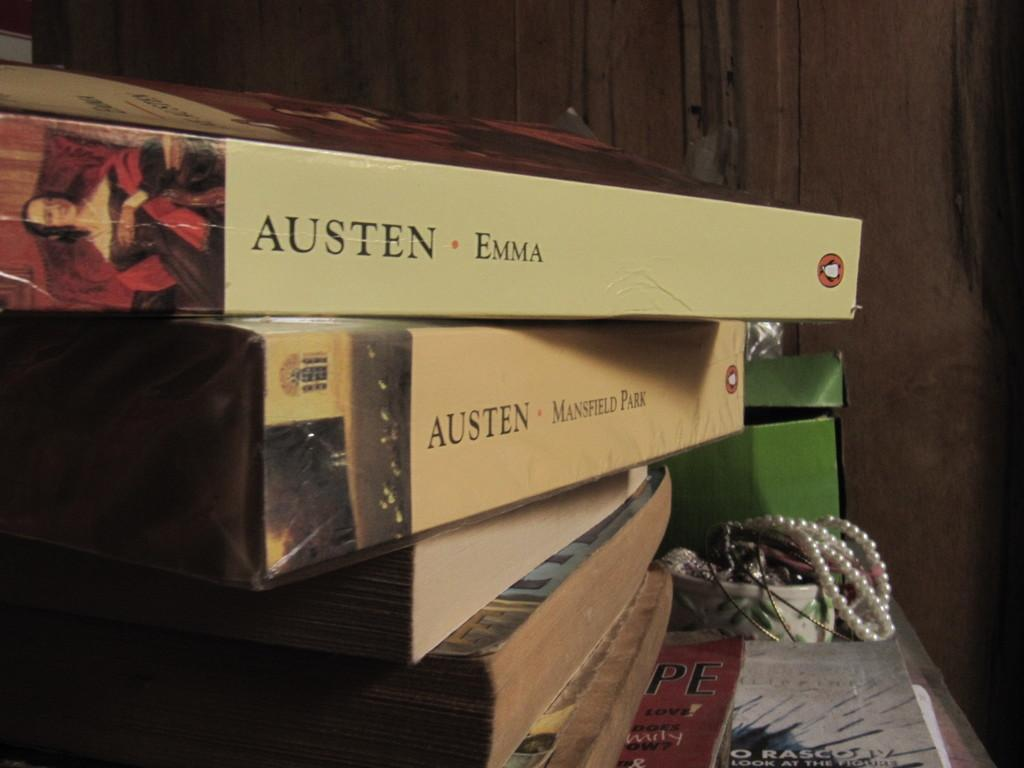<image>
Share a concise interpretation of the image provided. Two of Austen's books, Emma and Mansfield Park, are on top of other books. 